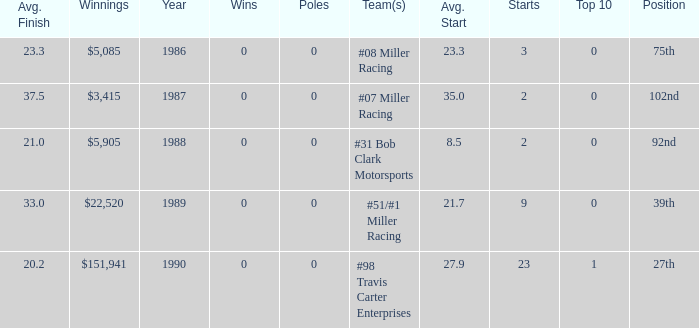Give me the full table as a dictionary. {'header': ['Avg. Finish', 'Winnings', 'Year', 'Wins', 'Poles', 'Team(s)', 'Avg. Start', 'Starts', 'Top 10', 'Position'], 'rows': [['23.3', '$5,085', '1986', '0', '0', '#08 Miller Racing', '23.3', '3', '0', '75th'], ['37.5', '$3,415', '1987', '0', '0', '#07 Miller Racing', '35.0', '2', '0', '102nd'], ['21.0', '$5,905', '1988', '0', '0', '#31 Bob Clark Motorsports', '8.5', '2', '0', '92nd'], ['33.0', '$22,520', '1989', '0', '0', '#51/#1 Miller Racing', '21.7', '9', '0', '39th'], ['20.2', '$151,941', '1990', '0', '0', '#98 Travis Carter Enterprises', '27.9', '23', '1', '27th']]} What racing team/s had the 92nd position? #31 Bob Clark Motorsports. 